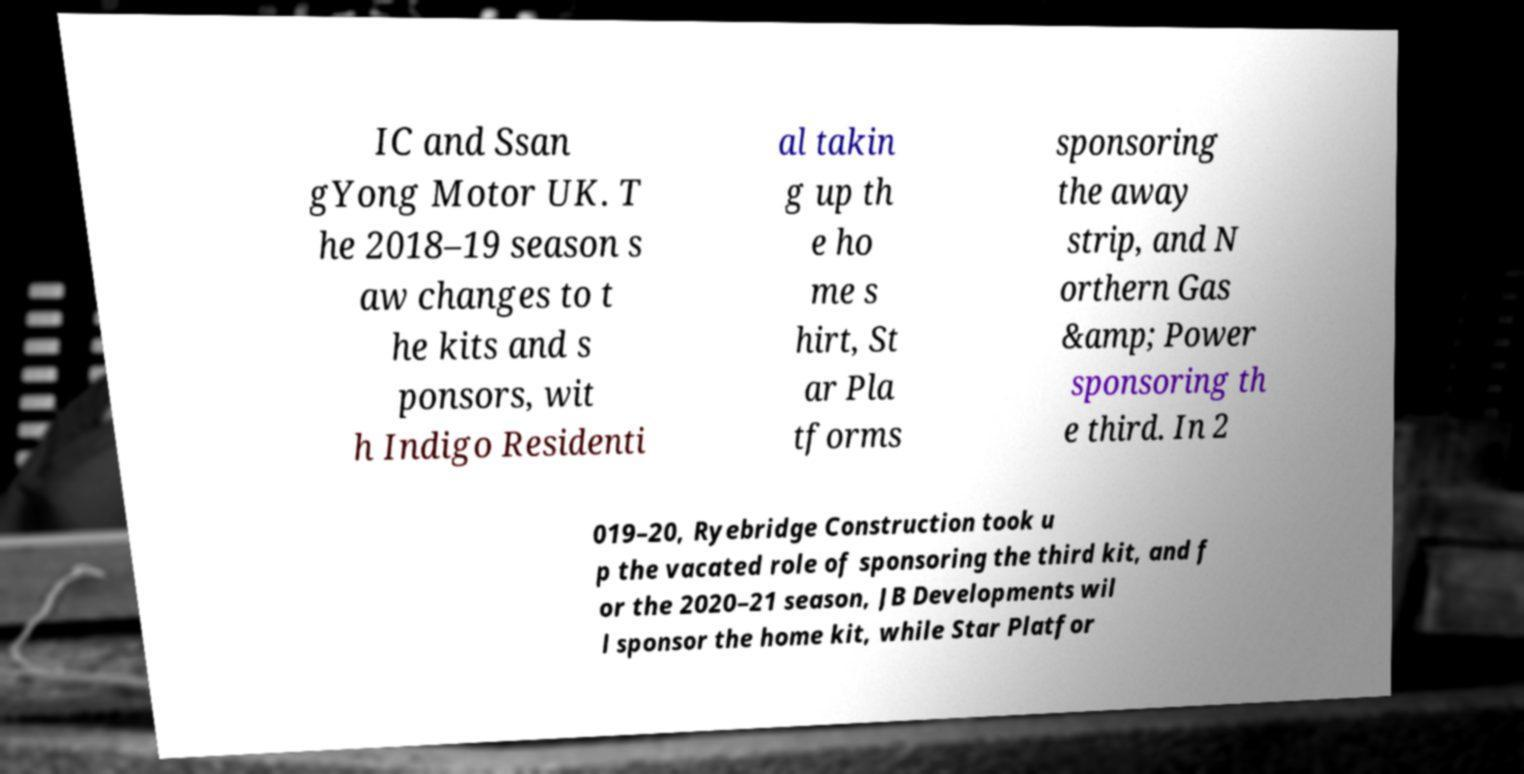I need the written content from this picture converted into text. Can you do that? IC and Ssan gYong Motor UK. T he 2018–19 season s aw changes to t he kits and s ponsors, wit h Indigo Residenti al takin g up th e ho me s hirt, St ar Pla tforms sponsoring the away strip, and N orthern Gas &amp; Power sponsoring th e third. In 2 019–20, Ryebridge Construction took u p the vacated role of sponsoring the third kit, and f or the 2020–21 season, JB Developments wil l sponsor the home kit, while Star Platfor 